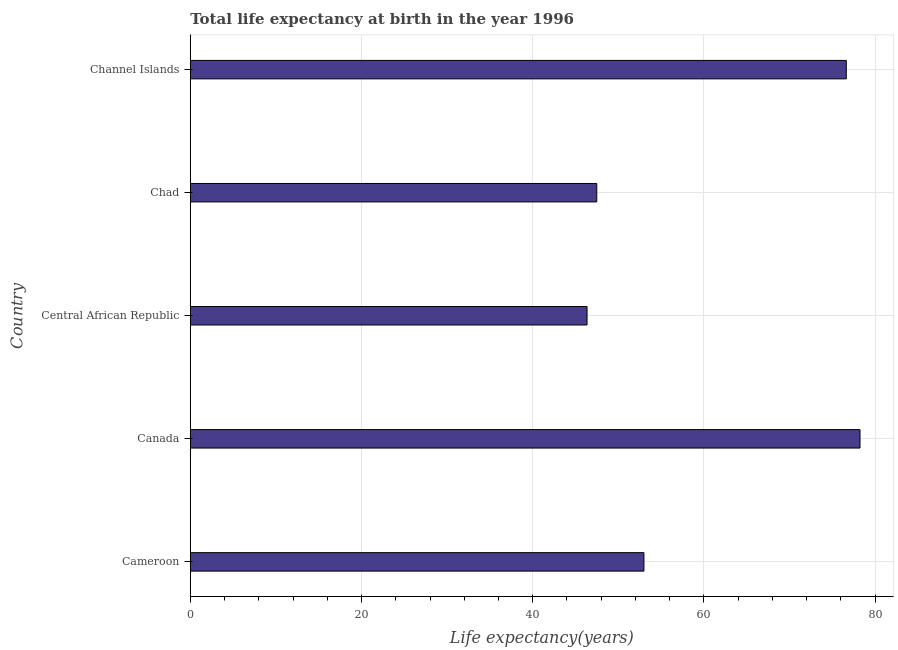What is the title of the graph?
Your answer should be very brief. Total life expectancy at birth in the year 1996. What is the label or title of the X-axis?
Your answer should be very brief. Life expectancy(years). What is the label or title of the Y-axis?
Make the answer very short. Country. What is the life expectancy at birth in Cameroon?
Offer a terse response. 52.99. Across all countries, what is the maximum life expectancy at birth?
Keep it short and to the point. 78.23. Across all countries, what is the minimum life expectancy at birth?
Give a very brief answer. 46.35. In which country was the life expectancy at birth maximum?
Keep it short and to the point. Canada. In which country was the life expectancy at birth minimum?
Offer a very short reply. Central African Republic. What is the sum of the life expectancy at birth?
Your response must be concise. 301.68. What is the difference between the life expectancy at birth in Canada and Chad?
Make the answer very short. 30.75. What is the average life expectancy at birth per country?
Offer a very short reply. 60.34. What is the median life expectancy at birth?
Your response must be concise. 52.99. Is the life expectancy at birth in Central African Republic less than that in Channel Islands?
Ensure brevity in your answer.  Yes. What is the difference between the highest and the second highest life expectancy at birth?
Provide a short and direct response. 1.6. Is the sum of the life expectancy at birth in Canada and Central African Republic greater than the maximum life expectancy at birth across all countries?
Offer a terse response. Yes. What is the difference between the highest and the lowest life expectancy at birth?
Your answer should be very brief. 31.88. How many bars are there?
Keep it short and to the point. 5. Are all the bars in the graph horizontal?
Ensure brevity in your answer.  Yes. What is the difference between two consecutive major ticks on the X-axis?
Your answer should be very brief. 20. Are the values on the major ticks of X-axis written in scientific E-notation?
Ensure brevity in your answer.  No. What is the Life expectancy(years) of Cameroon?
Make the answer very short. 52.99. What is the Life expectancy(years) in Canada?
Give a very brief answer. 78.23. What is the Life expectancy(years) of Central African Republic?
Offer a very short reply. 46.35. What is the Life expectancy(years) in Chad?
Provide a short and direct response. 47.48. What is the Life expectancy(years) of Channel Islands?
Provide a short and direct response. 76.63. What is the difference between the Life expectancy(years) in Cameroon and Canada?
Your answer should be very brief. -25.24. What is the difference between the Life expectancy(years) in Cameroon and Central African Republic?
Ensure brevity in your answer.  6.65. What is the difference between the Life expectancy(years) in Cameroon and Chad?
Offer a very short reply. 5.51. What is the difference between the Life expectancy(years) in Cameroon and Channel Islands?
Your answer should be very brief. -23.64. What is the difference between the Life expectancy(years) in Canada and Central African Republic?
Provide a succinct answer. 31.89. What is the difference between the Life expectancy(years) in Canada and Chad?
Your answer should be compact. 30.75. What is the difference between the Life expectancy(years) in Canada and Channel Islands?
Your response must be concise. 1.6. What is the difference between the Life expectancy(years) in Central African Republic and Chad?
Your response must be concise. -1.14. What is the difference between the Life expectancy(years) in Central African Republic and Channel Islands?
Your response must be concise. -30.28. What is the difference between the Life expectancy(years) in Chad and Channel Islands?
Offer a terse response. -29.15. What is the ratio of the Life expectancy(years) in Cameroon to that in Canada?
Keep it short and to the point. 0.68. What is the ratio of the Life expectancy(years) in Cameroon to that in Central African Republic?
Offer a very short reply. 1.14. What is the ratio of the Life expectancy(years) in Cameroon to that in Chad?
Offer a very short reply. 1.12. What is the ratio of the Life expectancy(years) in Cameroon to that in Channel Islands?
Keep it short and to the point. 0.69. What is the ratio of the Life expectancy(years) in Canada to that in Central African Republic?
Provide a short and direct response. 1.69. What is the ratio of the Life expectancy(years) in Canada to that in Chad?
Offer a terse response. 1.65. What is the ratio of the Life expectancy(years) in Central African Republic to that in Chad?
Offer a terse response. 0.98. What is the ratio of the Life expectancy(years) in Central African Republic to that in Channel Islands?
Your response must be concise. 0.6. What is the ratio of the Life expectancy(years) in Chad to that in Channel Islands?
Your response must be concise. 0.62. 